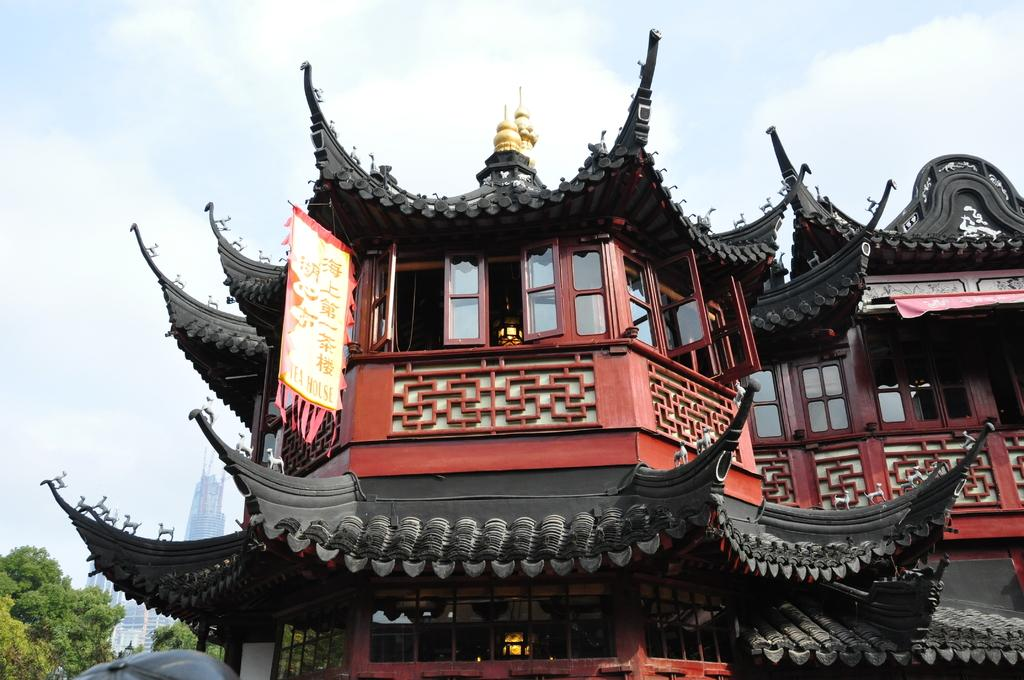What type of structure is present in the image? There is a building in the image. What is hanging on the building? A flag is hanging on the building. What is the color of the tomb in the image? The tomb is golden in color. What can be seen in the sky in the image? The sky is visible in the image. What type of vegetation is present in the image? There are trees in the image. How many crooks are sitting on the golden tomb in the image? There are no crooks present in the image; the tomb is golden in color, but no figures are depicted. 